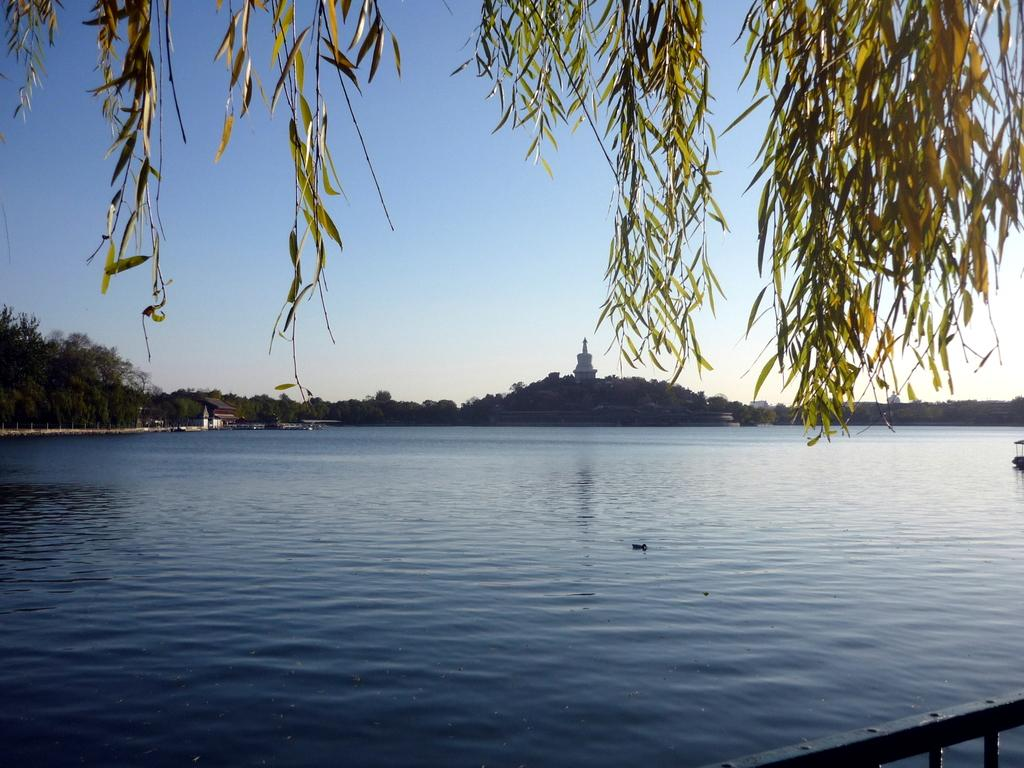What is the main subject in the center of the image? There is water in the center of the image. What type of vegetation can be seen in the image? There are trees in the image. What part of the trees is visible at the top of the image? Leaves are visible at the top of the image. How many loaves of bread are being pushed by the trees in the image? There are no loaves of bread or any pushing action depicted in the image. 